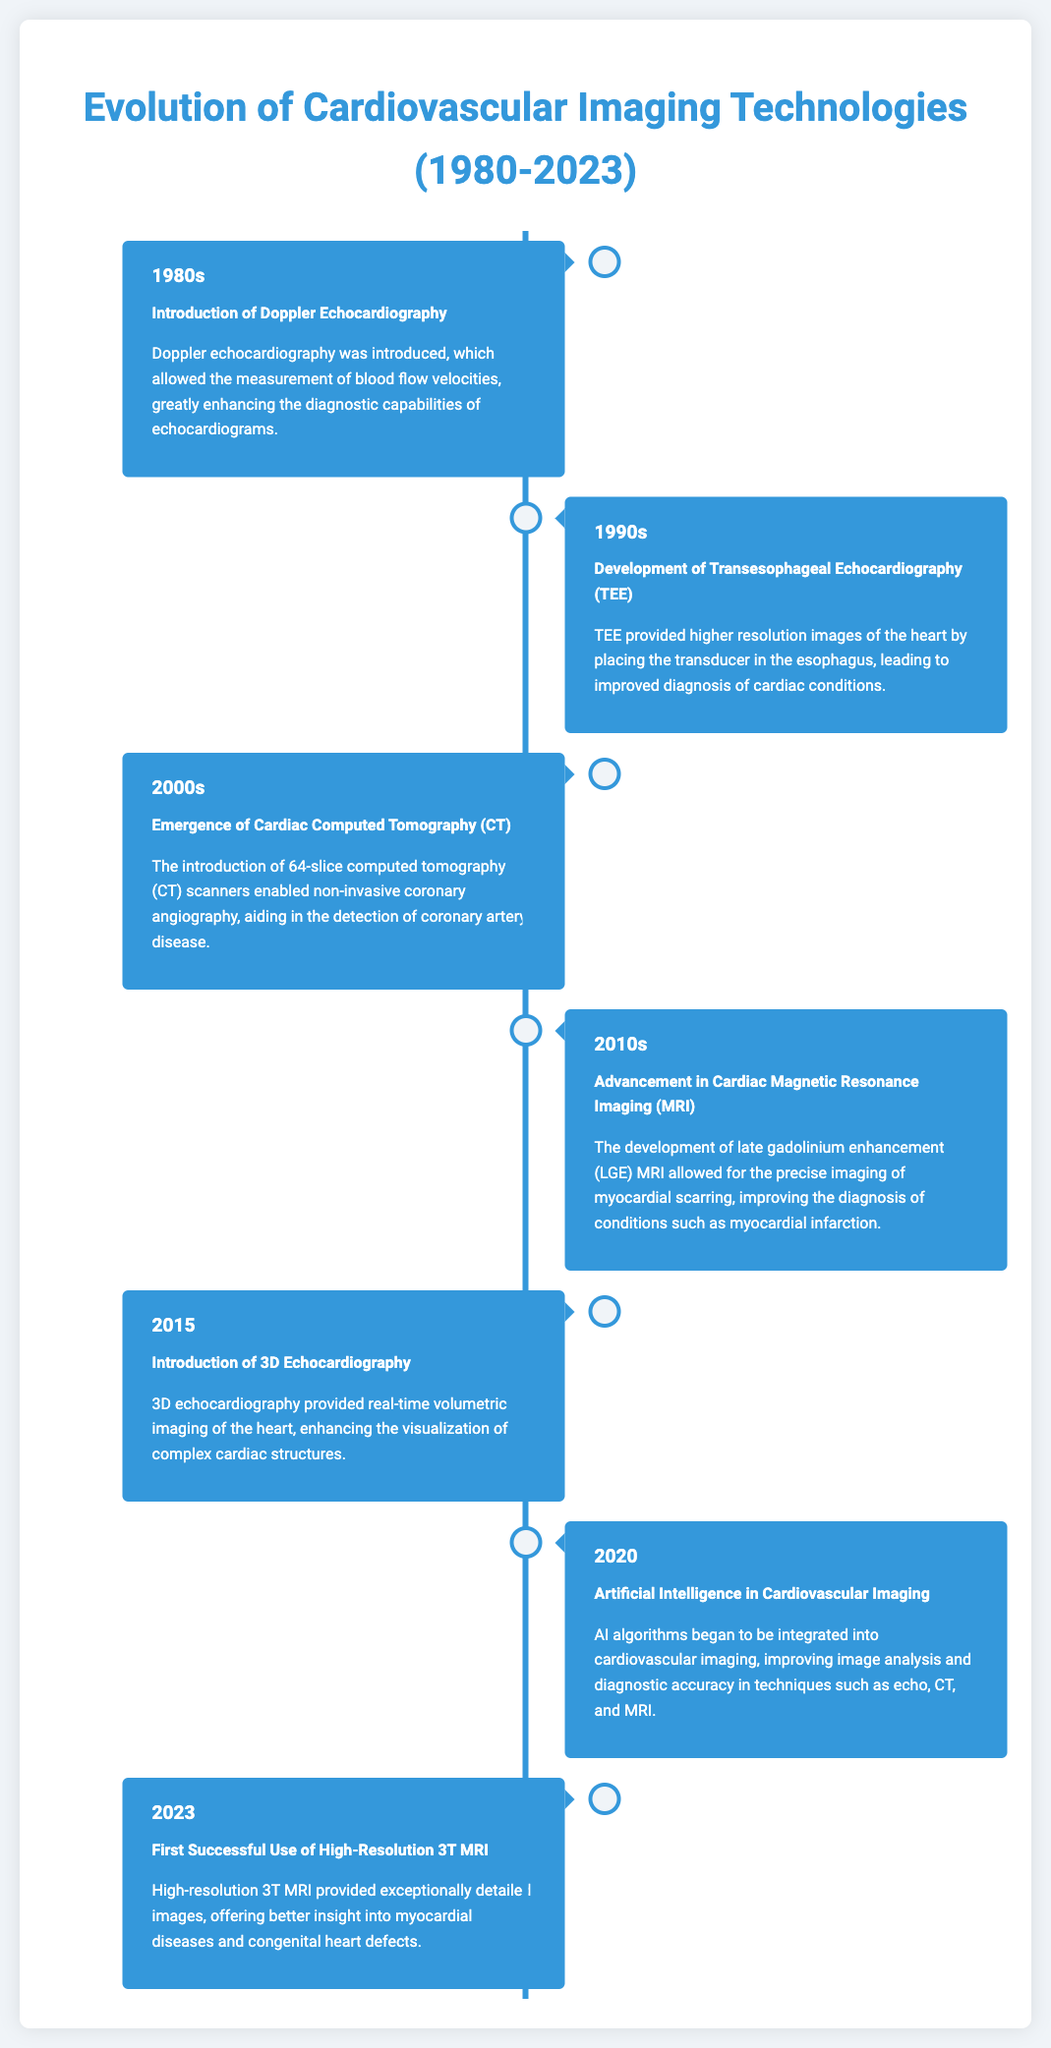What technology was introduced in the 1980s? The document states that Doppler echocardiography was introduced in the 1980s, marking a significant advancement in cardiovascular imaging.
Answer: Doppler echocardiography What year was transesophageal echocardiography developed? According to the timeline, transesophageal echocardiography (TEE) was developed in the 1990s.
Answer: 1990s What is the significance of 64-slice computed tomography? The timeline highlights that 64-slice computed tomography enabled non-invasive coronary angiography, which is crucial for diagnosing coronary artery disease.
Answer: Non-invasive coronary angiography Which imaging technique improved the diagnosis of myocardial infarction in the 2010s? The document mentions that late gadolinium enhancement (LGE) MRI improved diagnosis of conditions like myocardial infarction during the 2010s.
Answer: LGE MRI What new echocardiography method was introduced in 2015? The timeline indicates that 3D echocardiography was introduced in 2015, enhancing the visualization of the heart's complex structures.
Answer: 3D echocardiography What technological integration was highlighted in 2020? The document states that artificial intelligence was integrated into cardiovascular imaging in 2020, improving analysis and accuracy.
Answer: Artificial Intelligence What type of MRI was successfully used for the first time in 2023? According to the timeline, high-resolution 3T MRI was successfully used for the first time in 2023, providing detailed images of the heart.
Answer: High-resolution 3T MRI What does the timeline represent? The document is a timeline infographic depicting the evolution of cardiovascular imaging technologies from 1980 to 2023, showcasing significant advancements over the years.
Answer: Evolution of cardiovascular imaging technologies 